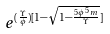<formula> <loc_0><loc_0><loc_500><loc_500>e ^ { ( \frac { \Upsilon } { \phi } ) [ 1 - \sqrt { 1 - \frac { 5 \phi ^ { 5 } m } { \Upsilon } } ] }</formula> 